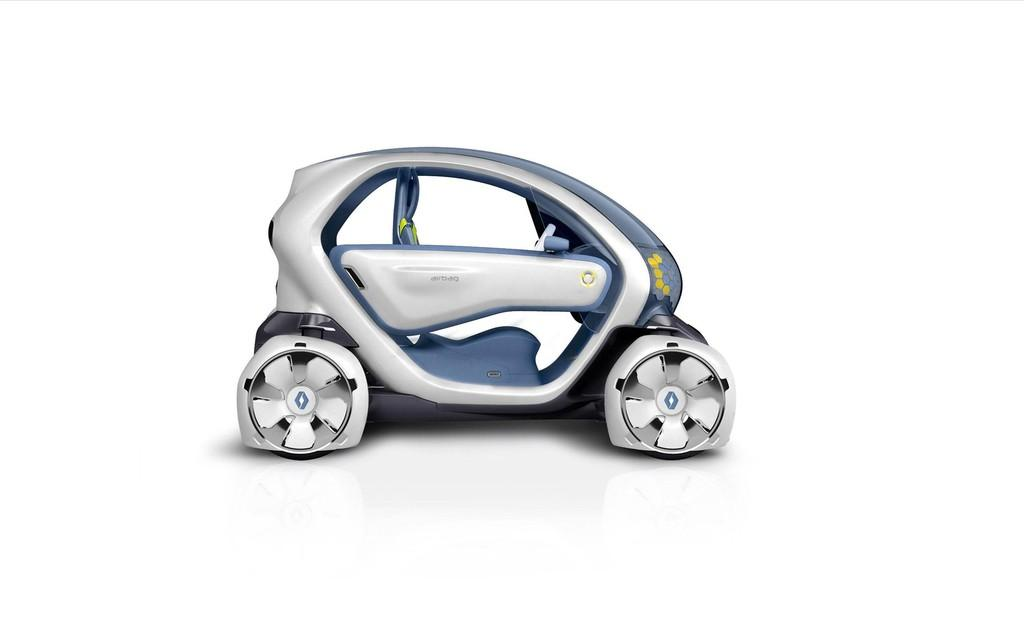What is the main subject of the image? There is a car in the image. What can be seen in the background of the image? The background of the image is white. What type of attack is being planned in the image? There is no indication of an attack or any plotting in the image; it simply features a car with a white background. What smell can be detected in the image? There is no mention of any smell or scent in the image; it only shows a car with a white background. 